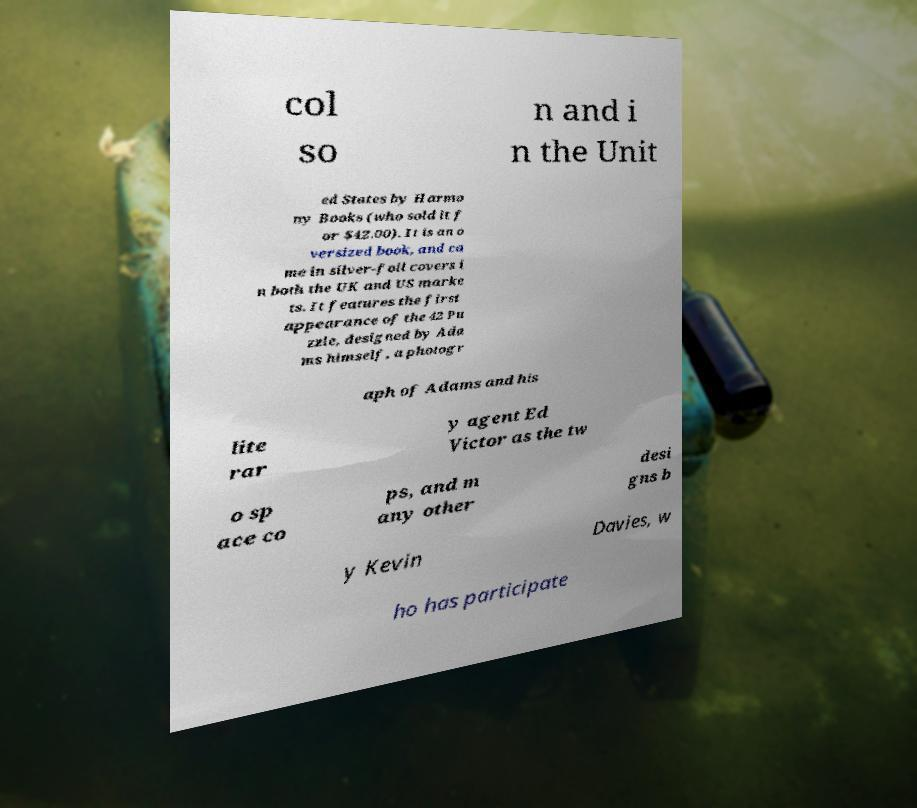Could you assist in decoding the text presented in this image and type it out clearly? col so n and i n the Unit ed States by Harmo ny Books (who sold it f or $42.00). It is an o versized book, and ca me in silver-foil covers i n both the UK and US marke ts. It features the first appearance of the 42 Pu zzle, designed by Ada ms himself, a photogr aph of Adams and his lite rar y agent Ed Victor as the tw o sp ace co ps, and m any other desi gns b y Kevin Davies, w ho has participate 